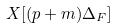<formula> <loc_0><loc_0><loc_500><loc_500>X [ ( p + m ) \Delta _ { F } ]</formula> 